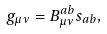<formula> <loc_0><loc_0><loc_500><loc_500>g _ { \mu \nu } = B _ { \mu \nu } ^ { a b } s _ { a b } ,</formula> 